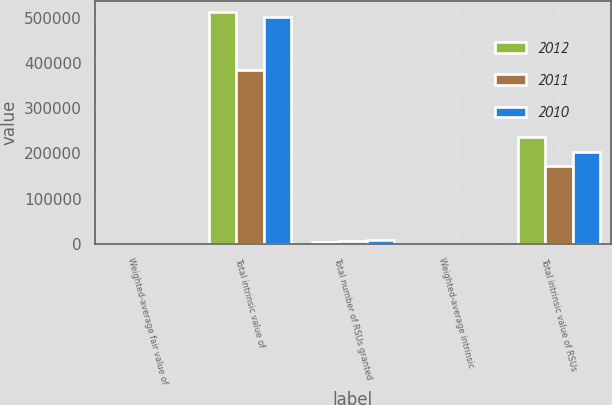<chart> <loc_0><loc_0><loc_500><loc_500><stacked_bar_chart><ecel><fcel>Weighted-average fair value of<fcel>Total intrinsic value of<fcel>Total number of RSUs granted<fcel>Weighted-average intrinsic<fcel>Total intrinsic value of RSUs<nl><fcel>2012<fcel>6.86<fcel>512636<fcel>4404<fcel>66.64<fcel>236575<nl><fcel>2011<fcel>7.79<fcel>385678<fcel>5333<fcel>63.87<fcel>173433<nl><fcel>2010<fcel>13.93<fcel>502354<fcel>8326<fcel>65.01<fcel>202717<nl></chart> 